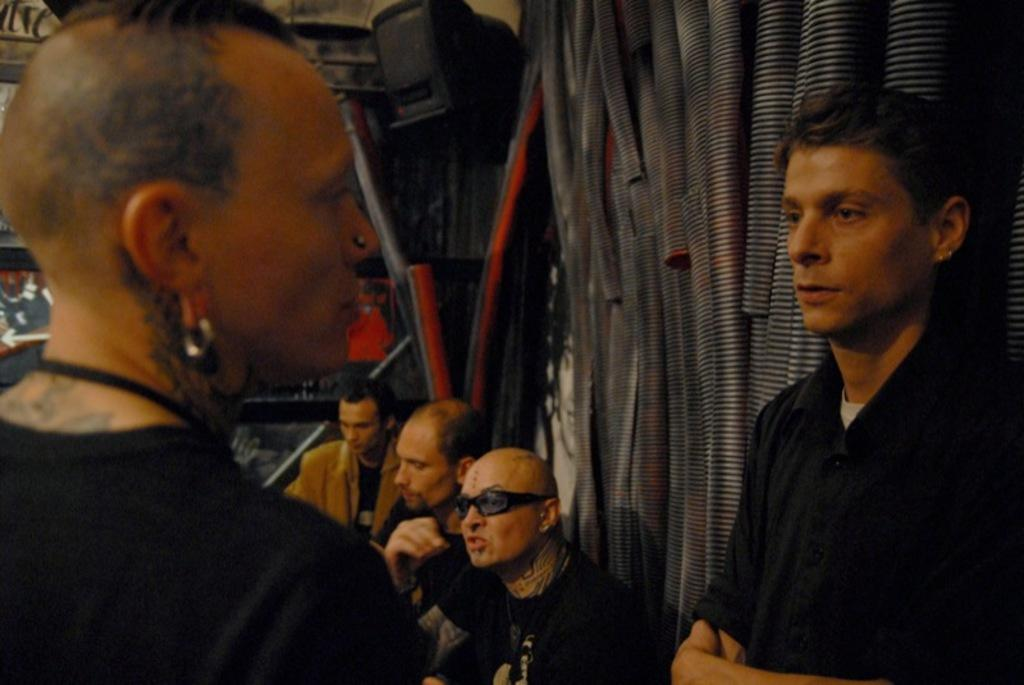How many people are standing in the image? There are two persons standing in front of each other. What are the standing persons wearing? Both persons are wearing black t-shirts. What can be seen on the wall behind the standing persons? There are pipes on the wall behind the standing persons. How many people are sitting behind the pipes? There are three persons sitting behind the pipes. What type of curtain is hanging in front of the standing persons? There is no curtain present in the image; the standing persons are in front of a wall with pipes. What message are the standing persons saying to each other before their flight? There is no indication of a flight or any conversation between the standing persons in the image. 